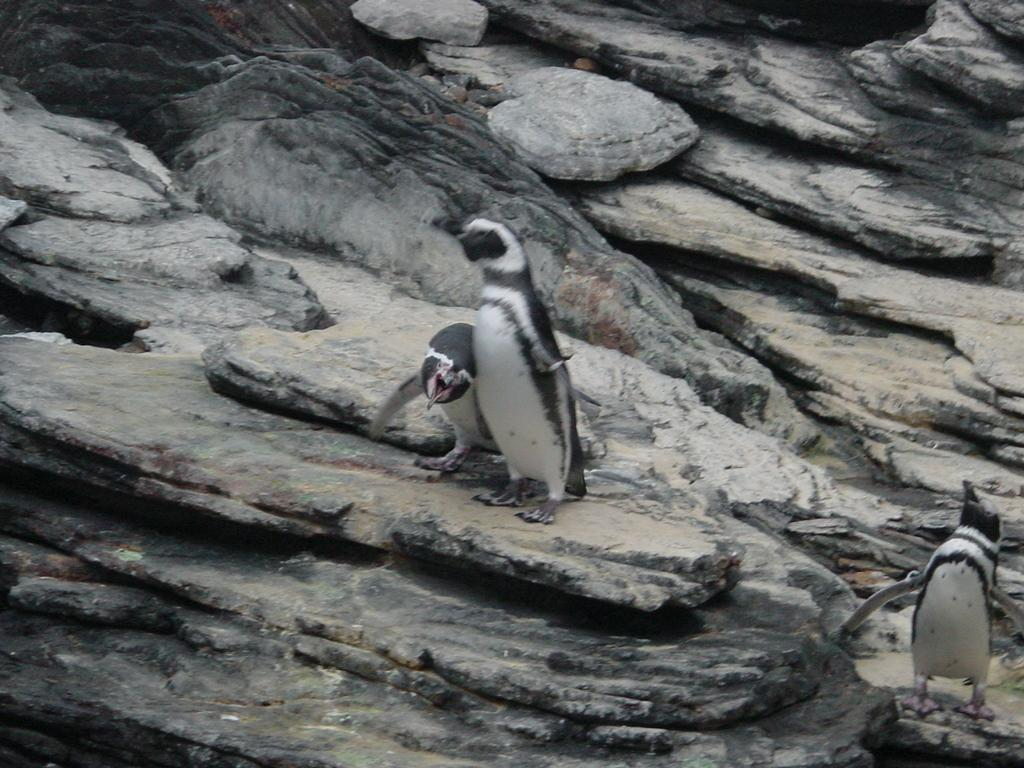How many penguins are in the image? There are three penguins in the image. What colors are the penguins in the image? The penguins are in white and black color. What are the penguins standing on? The penguins are standing on rocks. What can be seen in the background of the image? There are rocks visible in the background of the image. What sound can be heard coming from the plate in the image? There is no plate present in the image, so it is not possible to determine what sound might be heard. 